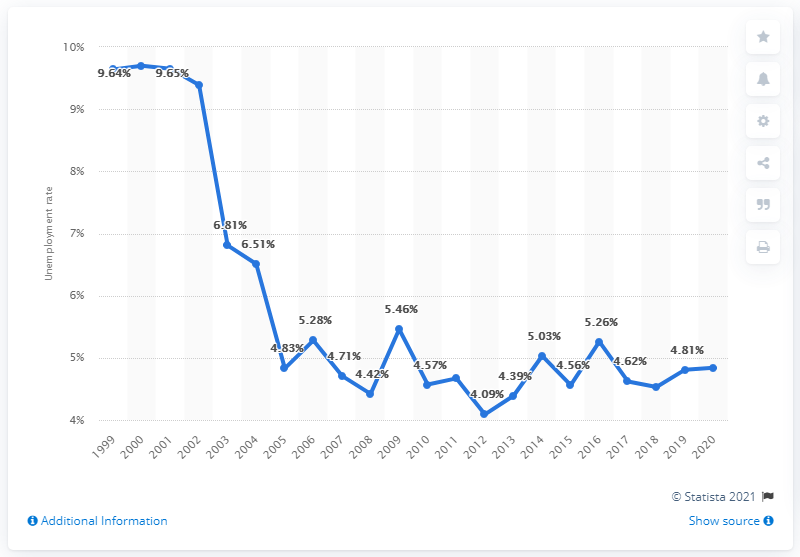Give some essential details in this illustration. According to data from 2020, the unemployment rate in Paraguay was 4.84%. 